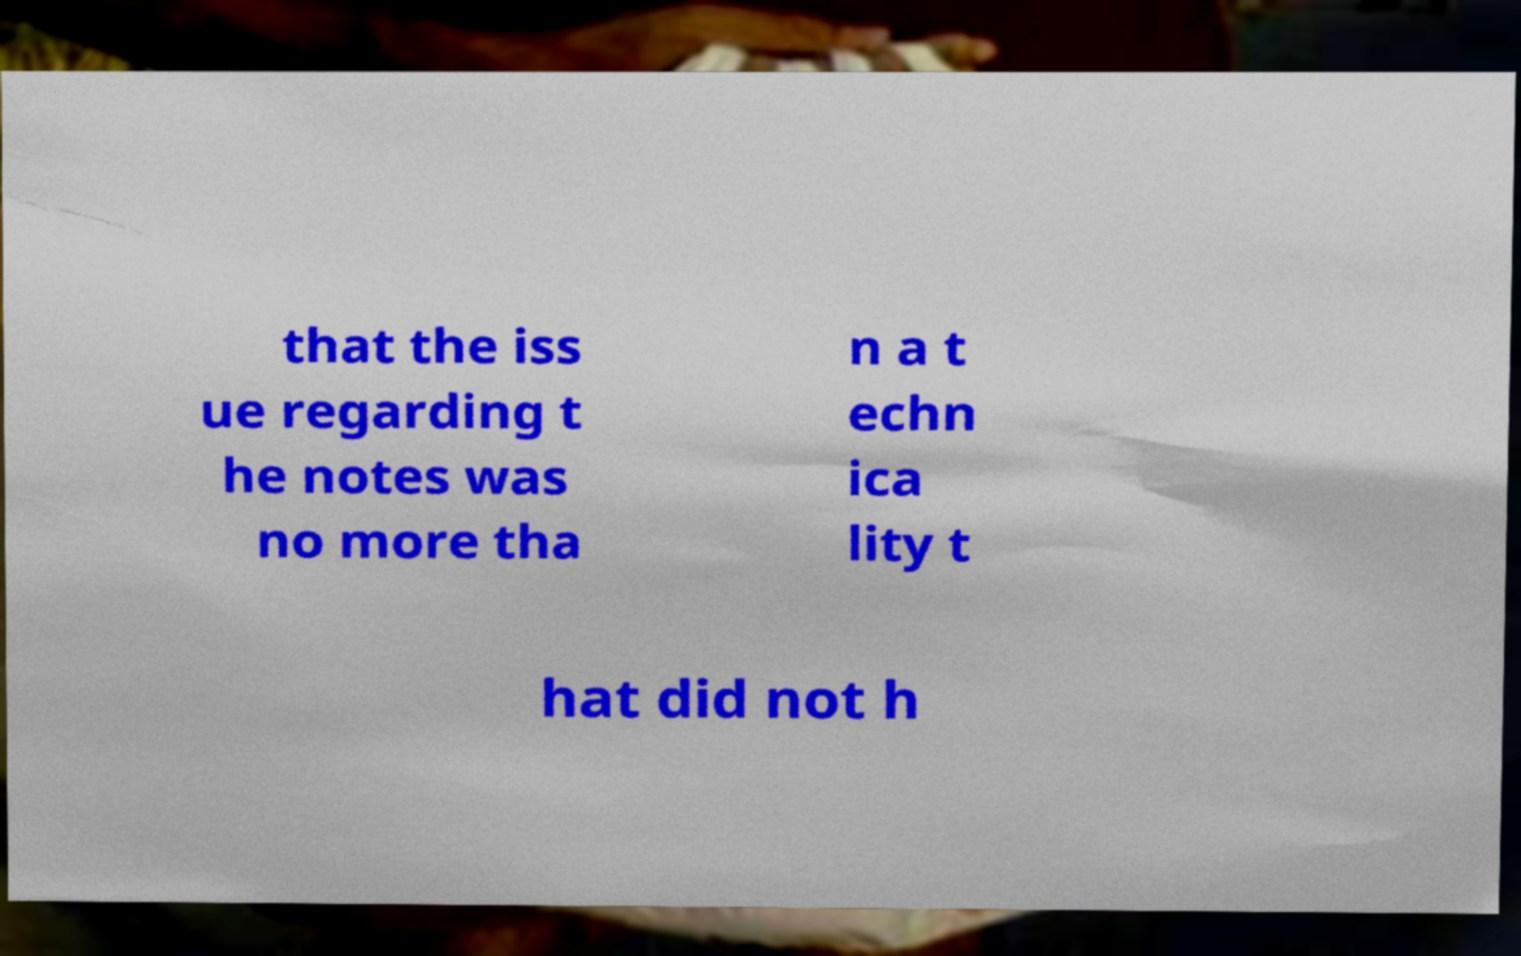Please read and relay the text visible in this image. What does it say? that the iss ue regarding t he notes was no more tha n a t echn ica lity t hat did not h 